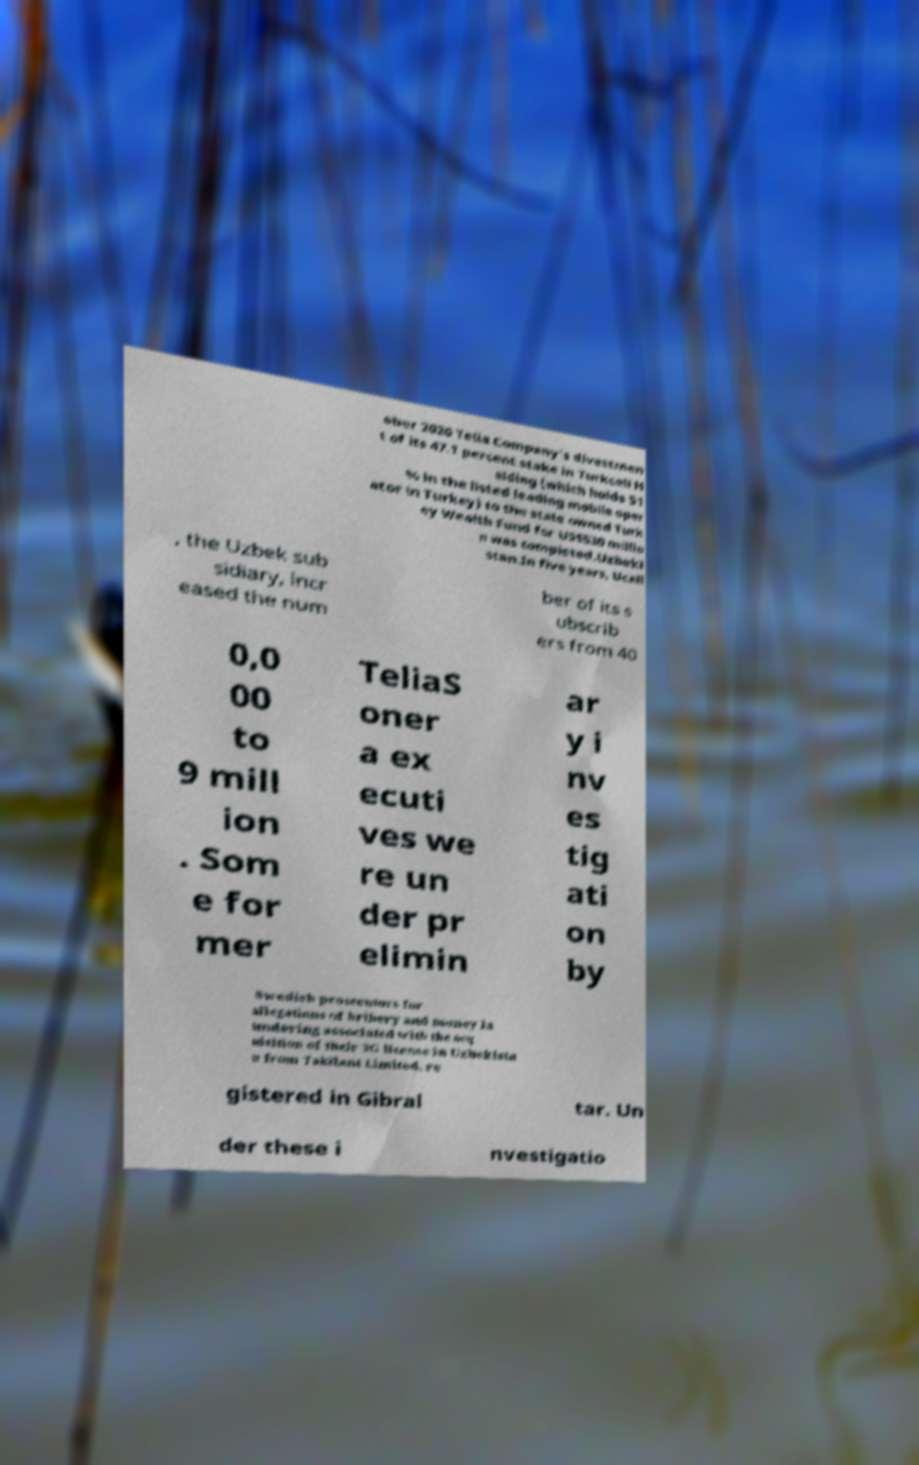What messages or text are displayed in this image? I need them in a readable, typed format. ober 2020 Telia Company's divestmen t of its 47.1 percent stake in Turkcell H olding (which holds 51 % in the listed leading mobile oper ator in Turkey) to the state owned Turk ey Wealth Fund for US$530 millio n was completed.Uzbeki stan.In five years, Ucell , the Uzbek sub sidiary, incr eased the num ber of its s ubscrib ers from 40 0,0 00 to 9 mill ion . Som e for mer TeliaS oner a ex ecuti ves we re un der pr elimin ar y i nv es tig ati on by Swedish prosecutors for allegations of bribery and money la undering associated with the acq uisition of their 3G license in Uzbekista n from Takilant Limited, re gistered in Gibral tar. Un der these i nvestigatio 